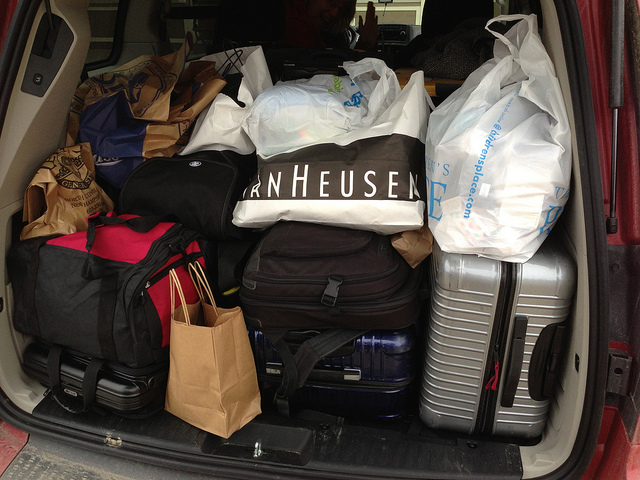Identify the text displayed in this image. AN HEUSEN E S birdrensplace.com P 